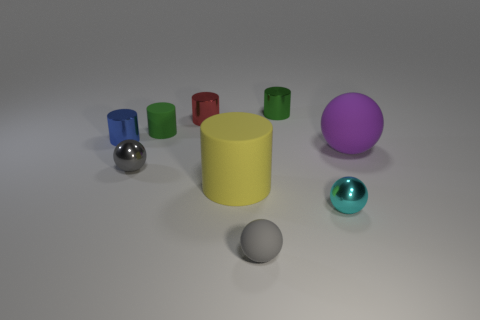Do the large object on the right side of the yellow cylinder and the small rubber thing that is to the left of the small red metal object have the same shape? no 